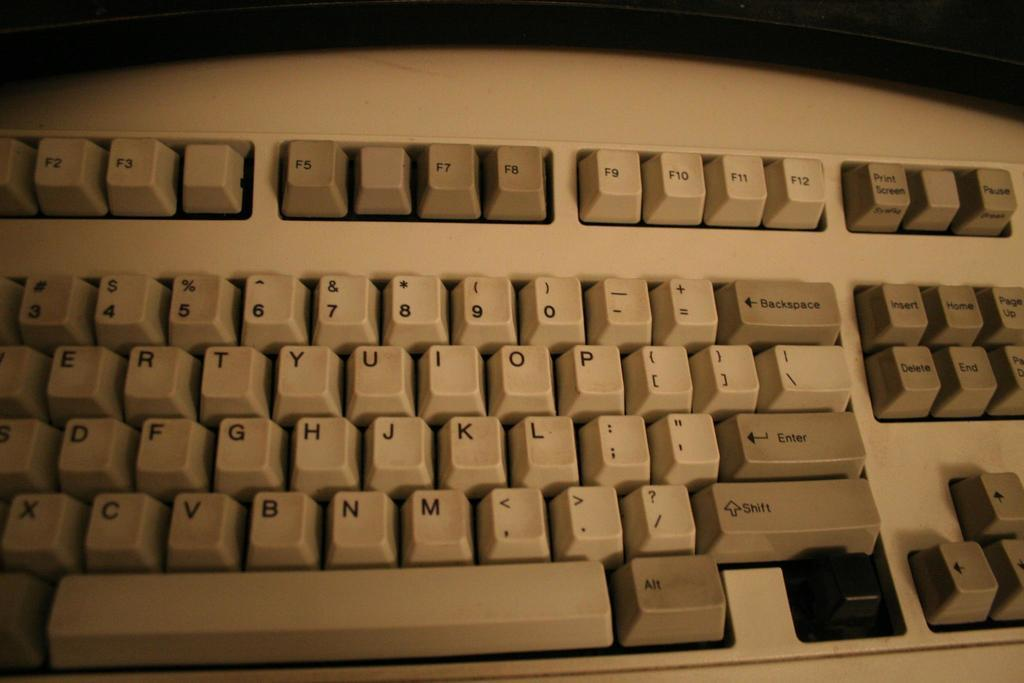<image>
Write a terse but informative summary of the picture. A very old IBM style keyboard F4 and F6 covers are missing between F3 and F7. 